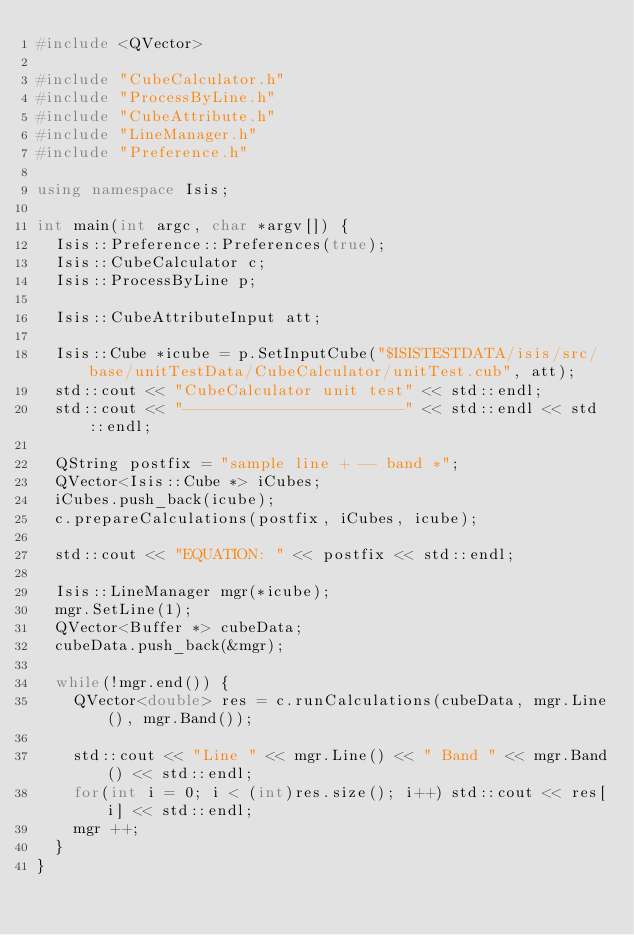Convert code to text. <code><loc_0><loc_0><loc_500><loc_500><_C++_>#include <QVector>

#include "CubeCalculator.h"
#include "ProcessByLine.h"
#include "CubeAttribute.h"
#include "LineManager.h"
#include "Preference.h"

using namespace Isis;

int main(int argc, char *argv[]) {
  Isis::Preference::Preferences(true);
  Isis::CubeCalculator c;
  Isis::ProcessByLine p;

  Isis::CubeAttributeInput att;

  Isis::Cube *icube = p.SetInputCube("$ISISTESTDATA/isis/src/base/unitTestData/CubeCalculator/unitTest.cub", att);
  std::cout << "CubeCalculator unit test" << std::endl;
  std::cout << "------------------------" << std::endl << std::endl;

  QString postfix = "sample line + -- band *";
  QVector<Isis::Cube *> iCubes;
  iCubes.push_back(icube);
  c.prepareCalculations(postfix, iCubes, icube);

  std::cout << "EQUATION: " << postfix << std::endl;

  Isis::LineManager mgr(*icube);
  mgr.SetLine(1);
  QVector<Buffer *> cubeData;
  cubeData.push_back(&mgr);

  while(!mgr.end()) {
    QVector<double> res = c.runCalculations(cubeData, mgr.Line(), mgr.Band());

    std::cout << "Line " << mgr.Line() << " Band " << mgr.Band() << std::endl;
    for(int i = 0; i < (int)res.size(); i++) std::cout << res[i] << std::endl;
    mgr ++;
  }
}
</code> 